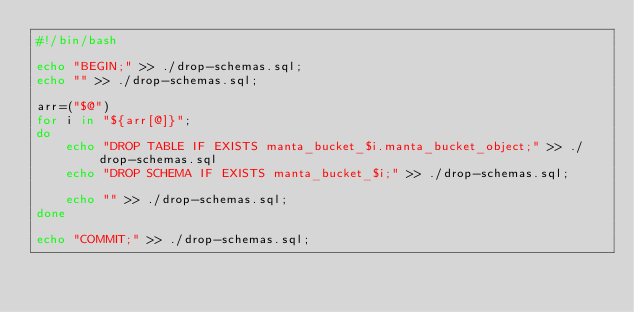<code> <loc_0><loc_0><loc_500><loc_500><_Bash_>#!/bin/bash

echo "BEGIN;" >> ./drop-schemas.sql;
echo "" >> ./drop-schemas.sql;

arr=("$@")
for i in "${arr[@]}";
do
    echo "DROP TABLE IF EXISTS manta_bucket_$i.manta_bucket_object;" >> ./drop-schemas.sql
    echo "DROP SCHEMA IF EXISTS manta_bucket_$i;" >> ./drop-schemas.sql;

    echo "" >> ./drop-schemas.sql;
done

echo "COMMIT;" >> ./drop-schemas.sql;
</code> 